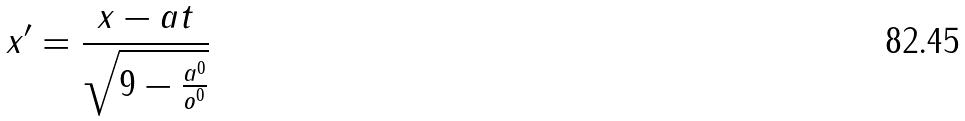Convert formula to latex. <formula><loc_0><loc_0><loc_500><loc_500>x ^ { \prime } = \frac { x - a t } { \sqrt { 9 - \frac { a ^ { 0 } } { o ^ { 0 } } } }</formula> 